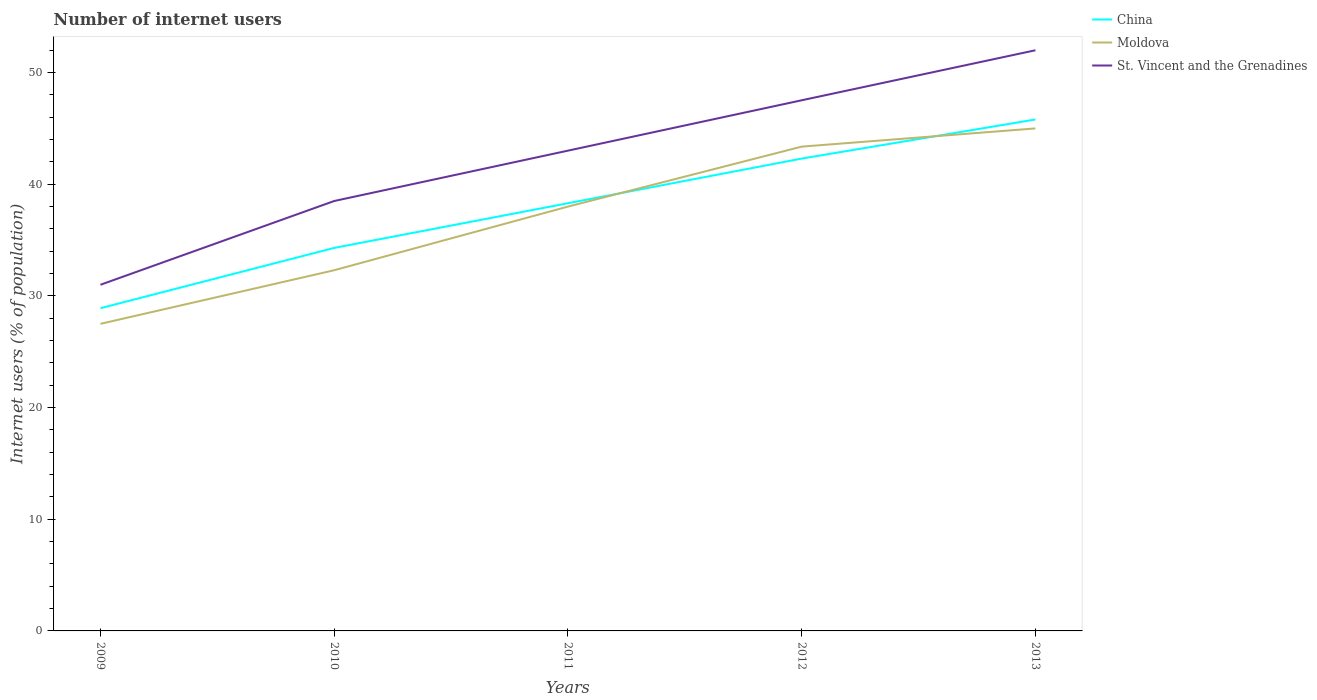Is the number of lines equal to the number of legend labels?
Provide a short and direct response. Yes. Across all years, what is the maximum number of internet users in St. Vincent and the Grenadines?
Your answer should be very brief. 31. In which year was the number of internet users in Moldova maximum?
Give a very brief answer. 2009. What is the total number of internet users in St. Vincent and the Grenadines in the graph?
Offer a very short reply. -4.51. Is the number of internet users in China strictly greater than the number of internet users in St. Vincent and the Grenadines over the years?
Provide a short and direct response. Yes. How many lines are there?
Offer a very short reply. 3. How many years are there in the graph?
Provide a short and direct response. 5. Does the graph contain any zero values?
Give a very brief answer. No. What is the title of the graph?
Ensure brevity in your answer.  Number of internet users. What is the label or title of the Y-axis?
Offer a very short reply. Internet users (% of population). What is the Internet users (% of population) in China in 2009?
Your response must be concise. 28.9. What is the Internet users (% of population) of Moldova in 2009?
Your answer should be compact. 27.5. What is the Internet users (% of population) in China in 2010?
Keep it short and to the point. 34.3. What is the Internet users (% of population) of Moldova in 2010?
Your answer should be compact. 32.3. What is the Internet users (% of population) in St. Vincent and the Grenadines in 2010?
Your response must be concise. 38.5. What is the Internet users (% of population) in China in 2011?
Your answer should be compact. 38.3. What is the Internet users (% of population) in St. Vincent and the Grenadines in 2011?
Your response must be concise. 43.01. What is the Internet users (% of population) of China in 2012?
Make the answer very short. 42.3. What is the Internet users (% of population) of Moldova in 2012?
Offer a terse response. 43.37. What is the Internet users (% of population) in St. Vincent and the Grenadines in 2012?
Give a very brief answer. 47.52. What is the Internet users (% of population) of China in 2013?
Offer a terse response. 45.8. What is the Internet users (% of population) of Moldova in 2013?
Provide a short and direct response. 45. Across all years, what is the maximum Internet users (% of population) of China?
Your answer should be compact. 45.8. Across all years, what is the minimum Internet users (% of population) in China?
Provide a succinct answer. 28.9. Across all years, what is the minimum Internet users (% of population) of St. Vincent and the Grenadines?
Offer a very short reply. 31. What is the total Internet users (% of population) in China in the graph?
Make the answer very short. 189.6. What is the total Internet users (% of population) of Moldova in the graph?
Make the answer very short. 186.17. What is the total Internet users (% of population) of St. Vincent and the Grenadines in the graph?
Your answer should be compact. 212.03. What is the difference between the Internet users (% of population) in China in 2009 and that in 2010?
Your answer should be very brief. -5.4. What is the difference between the Internet users (% of population) of Moldova in 2009 and that in 2010?
Make the answer very short. -4.8. What is the difference between the Internet users (% of population) in St. Vincent and the Grenadines in 2009 and that in 2010?
Give a very brief answer. -7.5. What is the difference between the Internet users (% of population) of St. Vincent and the Grenadines in 2009 and that in 2011?
Offer a very short reply. -12.01. What is the difference between the Internet users (% of population) of China in 2009 and that in 2012?
Give a very brief answer. -13.4. What is the difference between the Internet users (% of population) of Moldova in 2009 and that in 2012?
Give a very brief answer. -15.87. What is the difference between the Internet users (% of population) of St. Vincent and the Grenadines in 2009 and that in 2012?
Your answer should be very brief. -16.52. What is the difference between the Internet users (% of population) in China in 2009 and that in 2013?
Offer a very short reply. -16.9. What is the difference between the Internet users (% of population) of Moldova in 2009 and that in 2013?
Your answer should be very brief. -17.5. What is the difference between the Internet users (% of population) of Moldova in 2010 and that in 2011?
Keep it short and to the point. -5.7. What is the difference between the Internet users (% of population) of St. Vincent and the Grenadines in 2010 and that in 2011?
Provide a succinct answer. -4.51. What is the difference between the Internet users (% of population) in China in 2010 and that in 2012?
Keep it short and to the point. -8. What is the difference between the Internet users (% of population) in Moldova in 2010 and that in 2012?
Offer a terse response. -11.07. What is the difference between the Internet users (% of population) of St. Vincent and the Grenadines in 2010 and that in 2012?
Your answer should be compact. -9.02. What is the difference between the Internet users (% of population) of China in 2011 and that in 2012?
Your answer should be compact. -4. What is the difference between the Internet users (% of population) in Moldova in 2011 and that in 2012?
Provide a short and direct response. -5.37. What is the difference between the Internet users (% of population) in St. Vincent and the Grenadines in 2011 and that in 2012?
Ensure brevity in your answer.  -4.51. What is the difference between the Internet users (% of population) in St. Vincent and the Grenadines in 2011 and that in 2013?
Your answer should be very brief. -8.99. What is the difference between the Internet users (% of population) of China in 2012 and that in 2013?
Provide a short and direct response. -3.5. What is the difference between the Internet users (% of population) of Moldova in 2012 and that in 2013?
Offer a terse response. -1.63. What is the difference between the Internet users (% of population) in St. Vincent and the Grenadines in 2012 and that in 2013?
Offer a terse response. -4.48. What is the difference between the Internet users (% of population) of Moldova in 2009 and the Internet users (% of population) of St. Vincent and the Grenadines in 2010?
Keep it short and to the point. -11. What is the difference between the Internet users (% of population) in China in 2009 and the Internet users (% of population) in Moldova in 2011?
Give a very brief answer. -9.1. What is the difference between the Internet users (% of population) of China in 2009 and the Internet users (% of population) of St. Vincent and the Grenadines in 2011?
Give a very brief answer. -14.11. What is the difference between the Internet users (% of population) in Moldova in 2009 and the Internet users (% of population) in St. Vincent and the Grenadines in 2011?
Offer a very short reply. -15.51. What is the difference between the Internet users (% of population) of China in 2009 and the Internet users (% of population) of Moldova in 2012?
Provide a short and direct response. -14.47. What is the difference between the Internet users (% of population) of China in 2009 and the Internet users (% of population) of St. Vincent and the Grenadines in 2012?
Your answer should be compact. -18.62. What is the difference between the Internet users (% of population) in Moldova in 2009 and the Internet users (% of population) in St. Vincent and the Grenadines in 2012?
Your response must be concise. -20.02. What is the difference between the Internet users (% of population) of China in 2009 and the Internet users (% of population) of Moldova in 2013?
Provide a succinct answer. -16.1. What is the difference between the Internet users (% of population) in China in 2009 and the Internet users (% of population) in St. Vincent and the Grenadines in 2013?
Make the answer very short. -23.1. What is the difference between the Internet users (% of population) in Moldova in 2009 and the Internet users (% of population) in St. Vincent and the Grenadines in 2013?
Your answer should be very brief. -24.5. What is the difference between the Internet users (% of population) of China in 2010 and the Internet users (% of population) of Moldova in 2011?
Ensure brevity in your answer.  -3.7. What is the difference between the Internet users (% of population) in China in 2010 and the Internet users (% of population) in St. Vincent and the Grenadines in 2011?
Your response must be concise. -8.71. What is the difference between the Internet users (% of population) in Moldova in 2010 and the Internet users (% of population) in St. Vincent and the Grenadines in 2011?
Your answer should be compact. -10.71. What is the difference between the Internet users (% of population) in China in 2010 and the Internet users (% of population) in Moldova in 2012?
Your answer should be compact. -9.07. What is the difference between the Internet users (% of population) of China in 2010 and the Internet users (% of population) of St. Vincent and the Grenadines in 2012?
Ensure brevity in your answer.  -13.22. What is the difference between the Internet users (% of population) of Moldova in 2010 and the Internet users (% of population) of St. Vincent and the Grenadines in 2012?
Keep it short and to the point. -15.22. What is the difference between the Internet users (% of population) in China in 2010 and the Internet users (% of population) in St. Vincent and the Grenadines in 2013?
Ensure brevity in your answer.  -17.7. What is the difference between the Internet users (% of population) of Moldova in 2010 and the Internet users (% of population) of St. Vincent and the Grenadines in 2013?
Offer a very short reply. -19.7. What is the difference between the Internet users (% of population) of China in 2011 and the Internet users (% of population) of Moldova in 2012?
Your response must be concise. -5.07. What is the difference between the Internet users (% of population) in China in 2011 and the Internet users (% of population) in St. Vincent and the Grenadines in 2012?
Offer a very short reply. -9.22. What is the difference between the Internet users (% of population) of Moldova in 2011 and the Internet users (% of population) of St. Vincent and the Grenadines in 2012?
Offer a terse response. -9.52. What is the difference between the Internet users (% of population) in China in 2011 and the Internet users (% of population) in St. Vincent and the Grenadines in 2013?
Provide a succinct answer. -13.7. What is the difference between the Internet users (% of population) in Moldova in 2011 and the Internet users (% of population) in St. Vincent and the Grenadines in 2013?
Provide a succinct answer. -14. What is the difference between the Internet users (% of population) in China in 2012 and the Internet users (% of population) in Moldova in 2013?
Offer a terse response. -2.7. What is the difference between the Internet users (% of population) of China in 2012 and the Internet users (% of population) of St. Vincent and the Grenadines in 2013?
Keep it short and to the point. -9.7. What is the difference between the Internet users (% of population) of Moldova in 2012 and the Internet users (% of population) of St. Vincent and the Grenadines in 2013?
Offer a terse response. -8.63. What is the average Internet users (% of population) in China per year?
Keep it short and to the point. 37.92. What is the average Internet users (% of population) in Moldova per year?
Make the answer very short. 37.23. What is the average Internet users (% of population) in St. Vincent and the Grenadines per year?
Offer a very short reply. 42.41. In the year 2009, what is the difference between the Internet users (% of population) in China and Internet users (% of population) in St. Vincent and the Grenadines?
Your answer should be compact. -2.1. In the year 2009, what is the difference between the Internet users (% of population) of Moldova and Internet users (% of population) of St. Vincent and the Grenadines?
Offer a terse response. -3.5. In the year 2010, what is the difference between the Internet users (% of population) in China and Internet users (% of population) in St. Vincent and the Grenadines?
Offer a very short reply. -4.2. In the year 2010, what is the difference between the Internet users (% of population) of Moldova and Internet users (% of population) of St. Vincent and the Grenadines?
Offer a terse response. -6.2. In the year 2011, what is the difference between the Internet users (% of population) in China and Internet users (% of population) in St. Vincent and the Grenadines?
Your response must be concise. -4.71. In the year 2011, what is the difference between the Internet users (% of population) of Moldova and Internet users (% of population) of St. Vincent and the Grenadines?
Your answer should be very brief. -5.01. In the year 2012, what is the difference between the Internet users (% of population) in China and Internet users (% of population) in Moldova?
Give a very brief answer. -1.07. In the year 2012, what is the difference between the Internet users (% of population) of China and Internet users (% of population) of St. Vincent and the Grenadines?
Make the answer very short. -5.22. In the year 2012, what is the difference between the Internet users (% of population) of Moldova and Internet users (% of population) of St. Vincent and the Grenadines?
Offer a very short reply. -4.15. In the year 2013, what is the difference between the Internet users (% of population) of China and Internet users (% of population) of St. Vincent and the Grenadines?
Provide a short and direct response. -6.2. In the year 2013, what is the difference between the Internet users (% of population) of Moldova and Internet users (% of population) of St. Vincent and the Grenadines?
Offer a terse response. -7. What is the ratio of the Internet users (% of population) of China in 2009 to that in 2010?
Your response must be concise. 0.84. What is the ratio of the Internet users (% of population) of Moldova in 2009 to that in 2010?
Your response must be concise. 0.85. What is the ratio of the Internet users (% of population) of St. Vincent and the Grenadines in 2009 to that in 2010?
Provide a succinct answer. 0.81. What is the ratio of the Internet users (% of population) of China in 2009 to that in 2011?
Offer a very short reply. 0.75. What is the ratio of the Internet users (% of population) of Moldova in 2009 to that in 2011?
Offer a terse response. 0.72. What is the ratio of the Internet users (% of population) in St. Vincent and the Grenadines in 2009 to that in 2011?
Your answer should be very brief. 0.72. What is the ratio of the Internet users (% of population) in China in 2009 to that in 2012?
Keep it short and to the point. 0.68. What is the ratio of the Internet users (% of population) in Moldova in 2009 to that in 2012?
Offer a very short reply. 0.63. What is the ratio of the Internet users (% of population) in St. Vincent and the Grenadines in 2009 to that in 2012?
Your answer should be compact. 0.65. What is the ratio of the Internet users (% of population) of China in 2009 to that in 2013?
Make the answer very short. 0.63. What is the ratio of the Internet users (% of population) of Moldova in 2009 to that in 2013?
Your response must be concise. 0.61. What is the ratio of the Internet users (% of population) in St. Vincent and the Grenadines in 2009 to that in 2013?
Keep it short and to the point. 0.6. What is the ratio of the Internet users (% of population) in China in 2010 to that in 2011?
Give a very brief answer. 0.9. What is the ratio of the Internet users (% of population) of Moldova in 2010 to that in 2011?
Offer a terse response. 0.85. What is the ratio of the Internet users (% of population) in St. Vincent and the Grenadines in 2010 to that in 2011?
Make the answer very short. 0.9. What is the ratio of the Internet users (% of population) in China in 2010 to that in 2012?
Offer a very short reply. 0.81. What is the ratio of the Internet users (% of population) of Moldova in 2010 to that in 2012?
Make the answer very short. 0.74. What is the ratio of the Internet users (% of population) of St. Vincent and the Grenadines in 2010 to that in 2012?
Provide a short and direct response. 0.81. What is the ratio of the Internet users (% of population) in China in 2010 to that in 2013?
Your answer should be compact. 0.75. What is the ratio of the Internet users (% of population) of Moldova in 2010 to that in 2013?
Make the answer very short. 0.72. What is the ratio of the Internet users (% of population) of St. Vincent and the Grenadines in 2010 to that in 2013?
Your answer should be compact. 0.74. What is the ratio of the Internet users (% of population) in China in 2011 to that in 2012?
Your response must be concise. 0.91. What is the ratio of the Internet users (% of population) of Moldova in 2011 to that in 2012?
Give a very brief answer. 0.88. What is the ratio of the Internet users (% of population) of St. Vincent and the Grenadines in 2011 to that in 2012?
Offer a terse response. 0.91. What is the ratio of the Internet users (% of population) of China in 2011 to that in 2013?
Your response must be concise. 0.84. What is the ratio of the Internet users (% of population) of Moldova in 2011 to that in 2013?
Your answer should be very brief. 0.84. What is the ratio of the Internet users (% of population) in St. Vincent and the Grenadines in 2011 to that in 2013?
Provide a short and direct response. 0.83. What is the ratio of the Internet users (% of population) of China in 2012 to that in 2013?
Provide a short and direct response. 0.92. What is the ratio of the Internet users (% of population) in Moldova in 2012 to that in 2013?
Provide a succinct answer. 0.96. What is the ratio of the Internet users (% of population) in St. Vincent and the Grenadines in 2012 to that in 2013?
Your answer should be very brief. 0.91. What is the difference between the highest and the second highest Internet users (% of population) in China?
Your answer should be compact. 3.5. What is the difference between the highest and the second highest Internet users (% of population) of Moldova?
Keep it short and to the point. 1.63. What is the difference between the highest and the second highest Internet users (% of population) in St. Vincent and the Grenadines?
Offer a very short reply. 4.48. What is the difference between the highest and the lowest Internet users (% of population) of China?
Offer a very short reply. 16.9. What is the difference between the highest and the lowest Internet users (% of population) of Moldova?
Your answer should be compact. 17.5. 